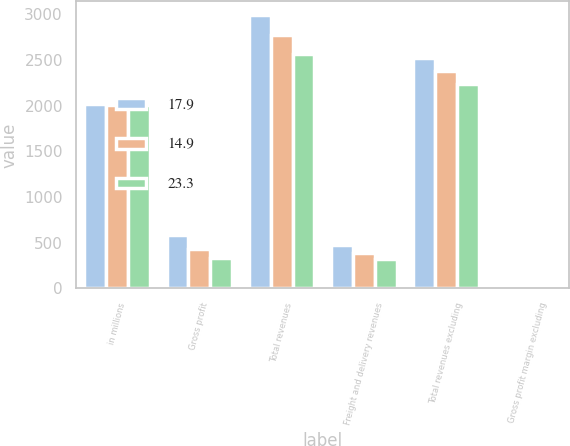<chart> <loc_0><loc_0><loc_500><loc_500><stacked_bar_chart><ecel><fcel>in millions<fcel>Gross profit<fcel>Total revenues<fcel>Freight and delivery revenues<fcel>Total revenues excluding<fcel>Gross profit margin excluding<nl><fcel>17.9<fcel>2014<fcel>587.6<fcel>2994.2<fcel>473.1<fcel>2521.1<fcel>23.3<nl><fcel>14.9<fcel>2013<fcel>426.9<fcel>2770.7<fcel>386.2<fcel>2384.5<fcel>17.9<nl><fcel>23.3<fcel>2012<fcel>334<fcel>2567.3<fcel>326.6<fcel>2240.7<fcel>14.9<nl></chart> 